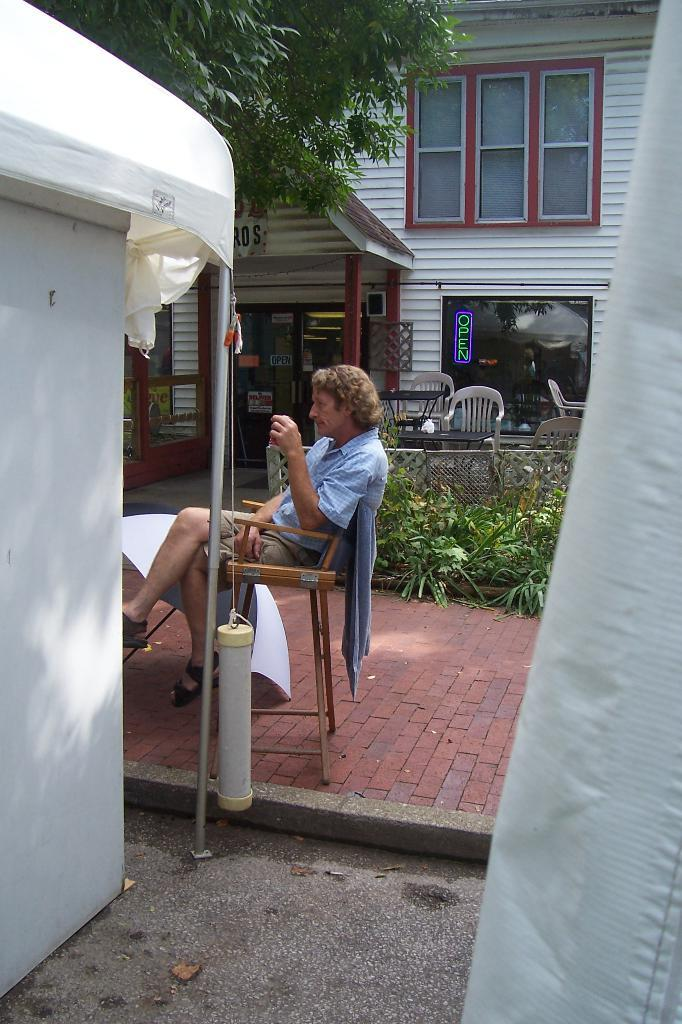What type of structures can be seen in the image? There are buildings in the image. What architectural features are visible in the buildings? There are windows, doors, and a net railing in the image. What type of vegetation is present in the image? There are plants and trees in the image. What is the person in the image doing? One person is sitting on a chair and holding something. What type of furniture is present in the image? There are chairs in the image. What organization is responsible for maintaining the pocket in the image? There is no pocket present in the image, so this question cannot be answered. How often does the wash cycle need to be changed in the image? There is no washing machine or any reference to washing in the image, so this question cannot be answered. 